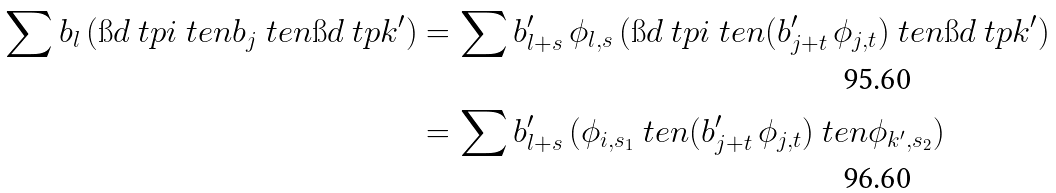<formula> <loc_0><loc_0><loc_500><loc_500>\sum b _ { l } \, ( \i d \ t p { i } \ t e n b _ { j } \ t e n \i d \ t p { k ^ { \prime } } ) & = \sum b ^ { \prime } _ { l + s } \, \phi _ { l , s } \, ( \i d \ t p { i } \ t e n ( b ^ { \prime } _ { j + t } \, \phi _ { j , t } ) \ t e n \i d \ t p { k ^ { \prime } } ) \\ & = \sum b ^ { \prime } _ { l + s } \, ( \phi _ { i , s _ { 1 } } \ t e n ( b ^ { \prime } _ { j + t } \, \phi _ { j , t } ) \ t e n \phi _ { k ^ { \prime } , s _ { 2 } } )</formula> 